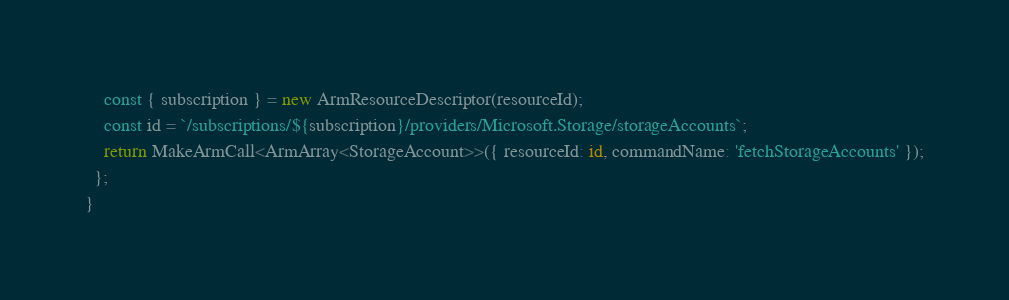<code> <loc_0><loc_0><loc_500><loc_500><_TypeScript_>    const { subscription } = new ArmResourceDescriptor(resourceId);
    const id = `/subscriptions/${subscription}/providers/Microsoft.Storage/storageAccounts`;
    return MakeArmCall<ArmArray<StorageAccount>>({ resourceId: id, commandName: 'fetchStorageAccounts' });
  };
}
</code> 